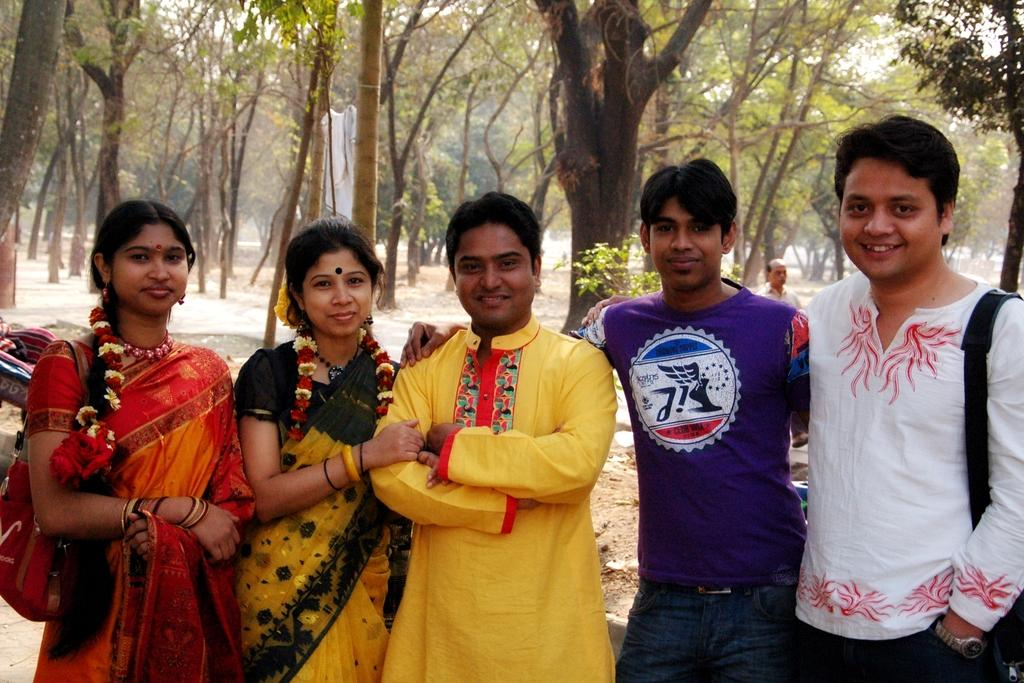How many men are in the image? There are 3 men in the image. How many women are in the image? There are 2 women in the image. What are the women wearing? The women are wearing sarees. What can be seen in the background of the image? There are trees and a person visible in the background, as well as the sky. What type of silver object is being used by the laborer in the image? There is no laborer or silver object present in the image. What type of farming equipment can be seen in the image? There is no farming equipment present in the image. 